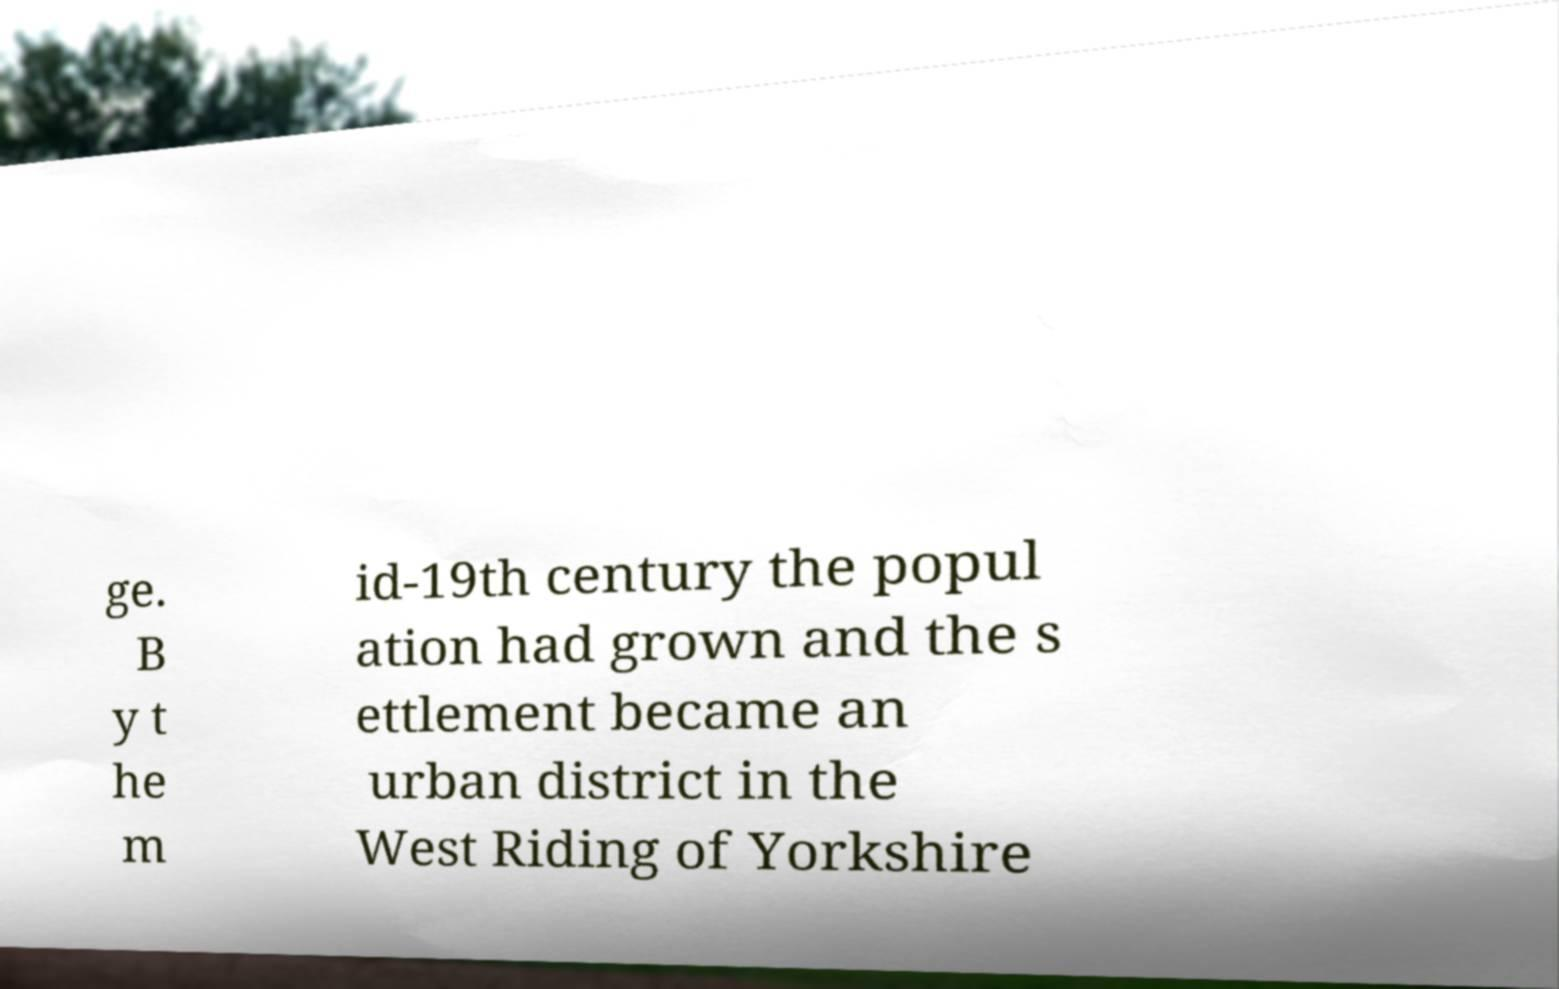Please read and relay the text visible in this image. What does it say? ge. B y t he m id-19th century the popul ation had grown and the s ettlement became an urban district in the West Riding of Yorkshire 